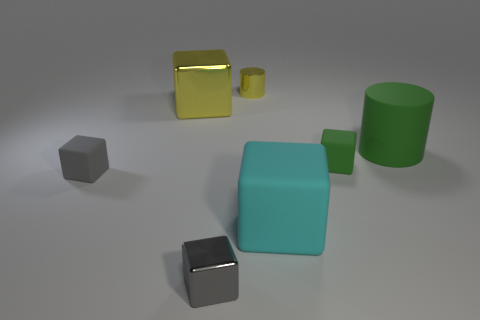What number of matte blocks have the same color as the large matte cylinder?
Provide a succinct answer. 1. There is a cube that is the same color as the big cylinder; what is it made of?
Make the answer very short. Rubber. There is a small thing behind the large green thing; what is its shape?
Your response must be concise. Cylinder. What is the color of the cylinder that is made of the same material as the cyan block?
Ensure brevity in your answer.  Green. There is a green object that is the same shape as the tiny yellow object; what material is it?
Your answer should be compact. Rubber. What is the shape of the tiny green rubber object?
Your answer should be compact. Cube. What is the material of the thing that is both left of the large green object and on the right side of the big rubber block?
Make the answer very short. Rubber. The gray thing that is the same material as the cyan cube is what shape?
Keep it short and to the point. Cube. What is the size of the cylinder that is made of the same material as the cyan cube?
Your answer should be very brief. Large. What is the shape of the shiny object that is behind the tiny metal block and to the left of the shiny cylinder?
Offer a very short reply. Cube. 